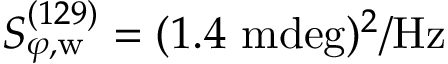<formula> <loc_0><loc_0><loc_500><loc_500>S _ { \varphi , w } ^ { ( 1 2 9 ) } = ( 1 . 4 m d e g ) ^ { 2 } / H z</formula> 